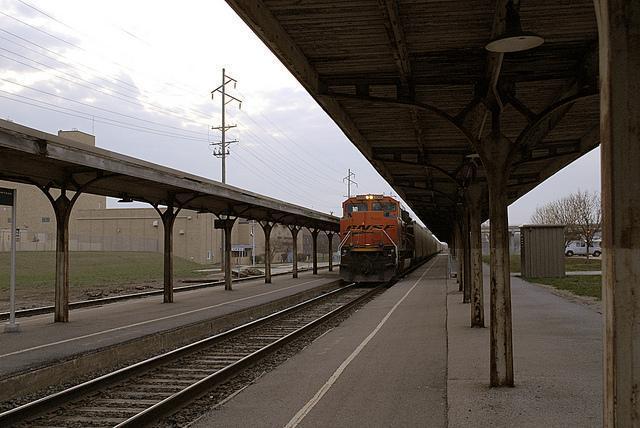How many sets of train tracks are there?
Give a very brief answer. 1. How many trains are there?
Give a very brief answer. 1. How many train tracks are there in this picture?
Give a very brief answer. 1. 